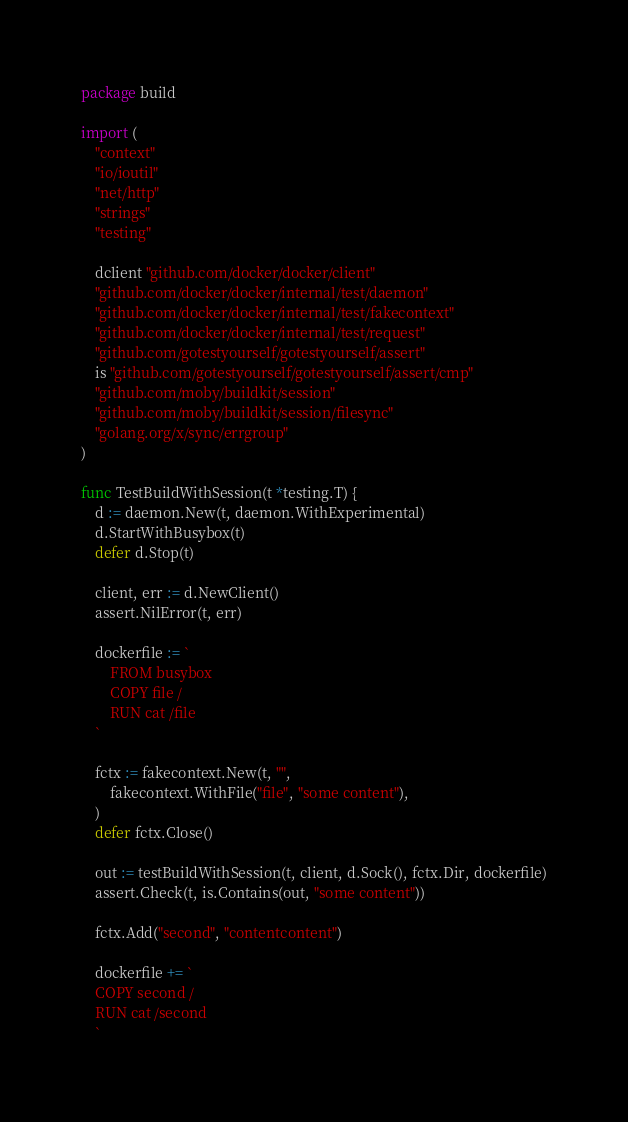Convert code to text. <code><loc_0><loc_0><loc_500><loc_500><_Go_>package build

import (
	"context"
	"io/ioutil"
	"net/http"
	"strings"
	"testing"

	dclient "github.com/docker/docker/client"
	"github.com/docker/docker/internal/test/daemon"
	"github.com/docker/docker/internal/test/fakecontext"
	"github.com/docker/docker/internal/test/request"
	"github.com/gotestyourself/gotestyourself/assert"
	is "github.com/gotestyourself/gotestyourself/assert/cmp"
	"github.com/moby/buildkit/session"
	"github.com/moby/buildkit/session/filesync"
	"golang.org/x/sync/errgroup"
)

func TestBuildWithSession(t *testing.T) {
	d := daemon.New(t, daemon.WithExperimental)
	d.StartWithBusybox(t)
	defer d.Stop(t)

	client, err := d.NewClient()
	assert.NilError(t, err)

	dockerfile := `
		FROM busybox
		COPY file /
		RUN cat /file
	`

	fctx := fakecontext.New(t, "",
		fakecontext.WithFile("file", "some content"),
	)
	defer fctx.Close()

	out := testBuildWithSession(t, client, d.Sock(), fctx.Dir, dockerfile)
	assert.Check(t, is.Contains(out, "some content"))

	fctx.Add("second", "contentcontent")

	dockerfile += `
	COPY second /
	RUN cat /second
	`
</code> 